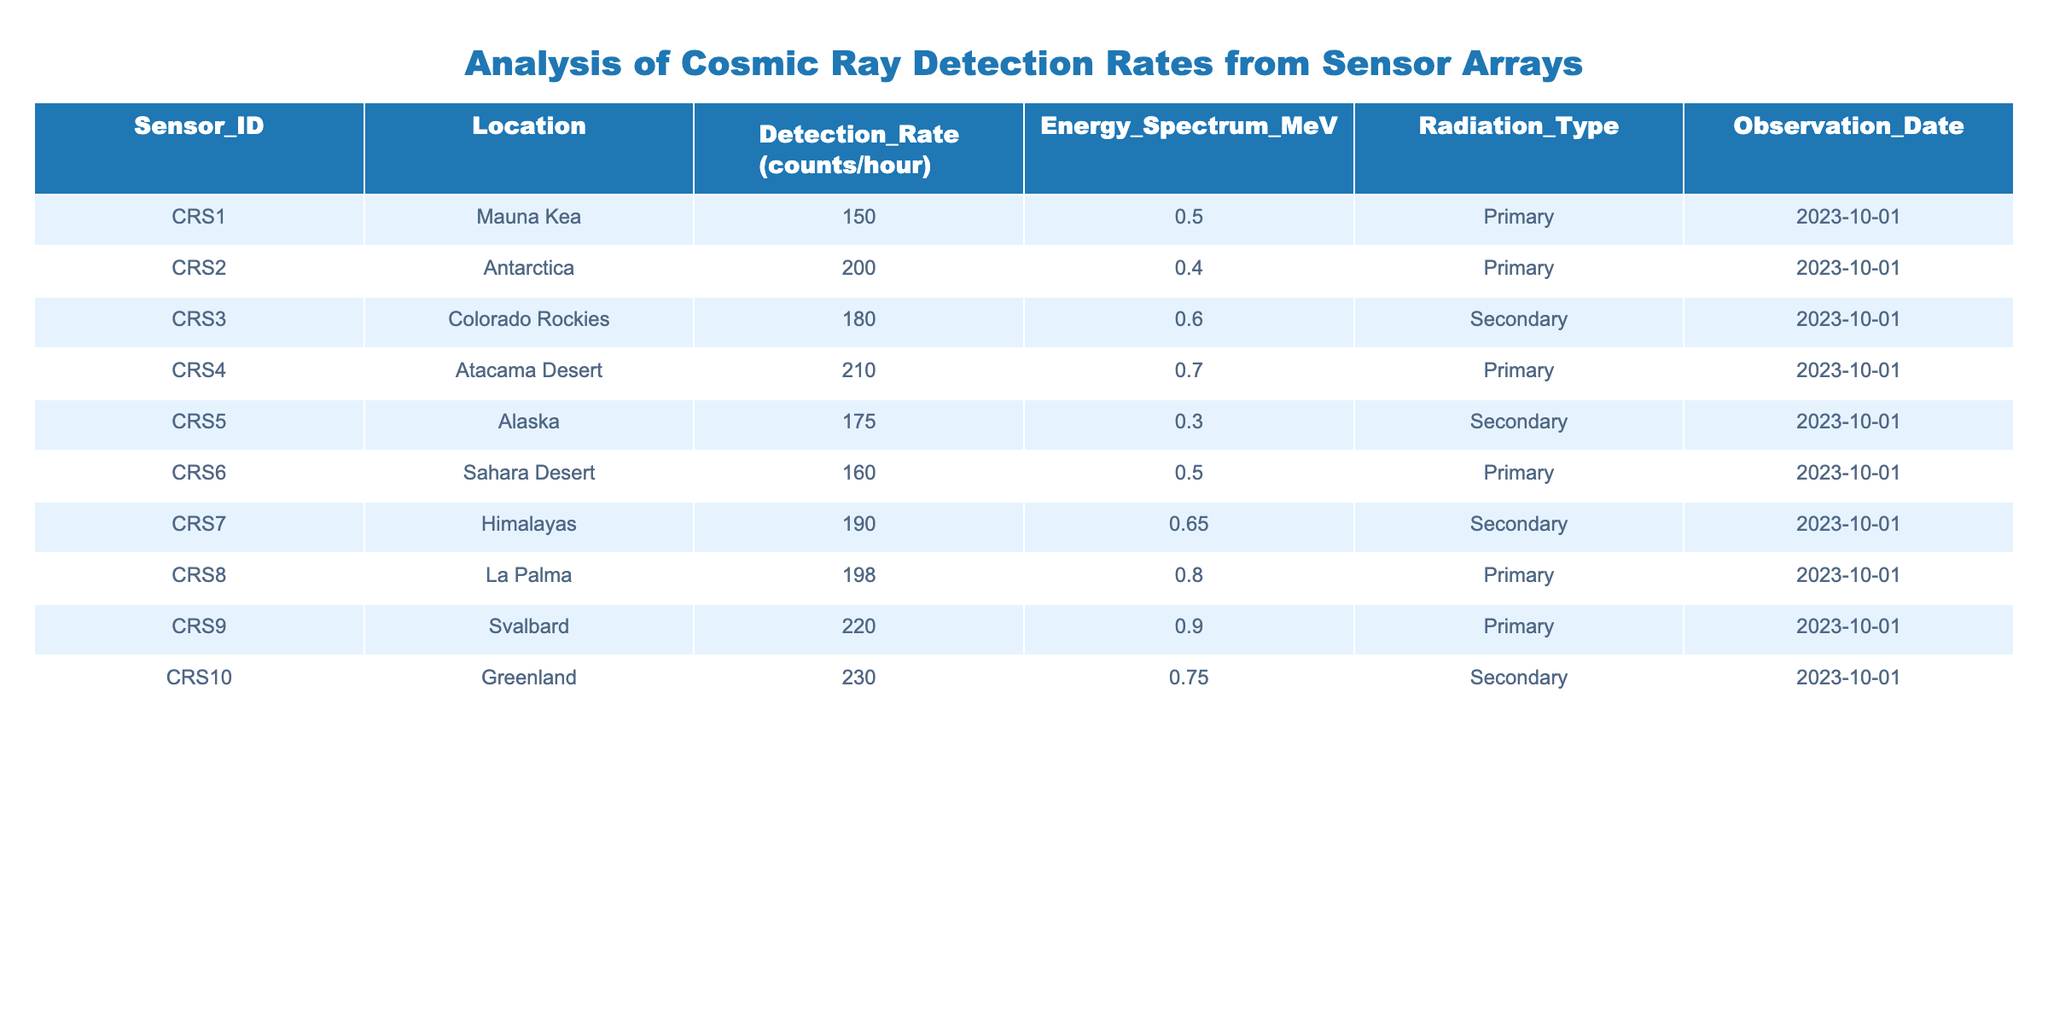What is the detection rate for the sensor located in Antarctica? The table indicates that for Antarctica (Sensor_ID: CRS2), the Detection_Rate is listed as 200 counts/hour.
Answer: 200 counts/hour What is the highest detection rate reported among the sensors? The highest detection rate listed in the table is for Greenland (Sensor_ID: CRS10), with a value of 230 counts/hour.
Answer: 230 counts/hour How many primary radiation type sensors are there? By examining the Radiation_Type column, we find CRS1, CRS2, CRS4, CRS6, CRS8, and CRS9 all labelled as Primary, giving us a total of 6 primary sensors.
Answer: 6 What is the average detection rate for secondary radiation type sensors? The secondary sensors listed are CRS3, CRS5, CRS7, and CRS10 with detection rates of 180, 175, 190, and 230 respectively. Summing these gives 180 + 175 + 190 + 230 = 775, and dividing by the number of sensors (4) results in an average of 775/4 = 193.75 counts/hour.
Answer: 193.75 counts/hour Is the detection rate in the Sahara Desert higher than 150 counts/hour? Looking at the table, the detection rate for Sahara Desert (Sensor_ID: CRS6) is 160 counts/hour, which is indeed higher than 150 counts/hour, making this statement true.
Answer: Yes What is the median energy spectrum of all sensors? The energy spectrum values from all sensors are 0.5, 0.4, 0.6, 0.7, 0.3, 0.5, 0.65, 0.8, 0.9, and 0.75. When we arrange these in ascending order (0.3, 0.4, 0.5, 0.5, 0.6, 0.65, 0.7, 0.75, 0.8, 0.9), the median (the average of the 5th and 6th values) is (0.6 + 0.65)/2 = 0.625 MeV.
Answer: 0.625 MeV Which location has the second highest detection rate and what is its value? Looking through the sorted detection rates, the highest is Greenland with 230 counts/hour, and the second highest is Svalbard (Sensor_ID: CRS9) at 220 counts/hour.
Answer: Svalbard, 220 counts/hour Is the average detection rate across all sensors above 180 counts/hour? Summing the detection rates (150 + 200 + 180 + 210 + 175 + 160 + 190 + 198 + 220 + 230 = 1875), and dividing by the total number of sensors (10) gives an average of 187.5 counts/hour, which is below 180 counts/hour.
Answer: No 